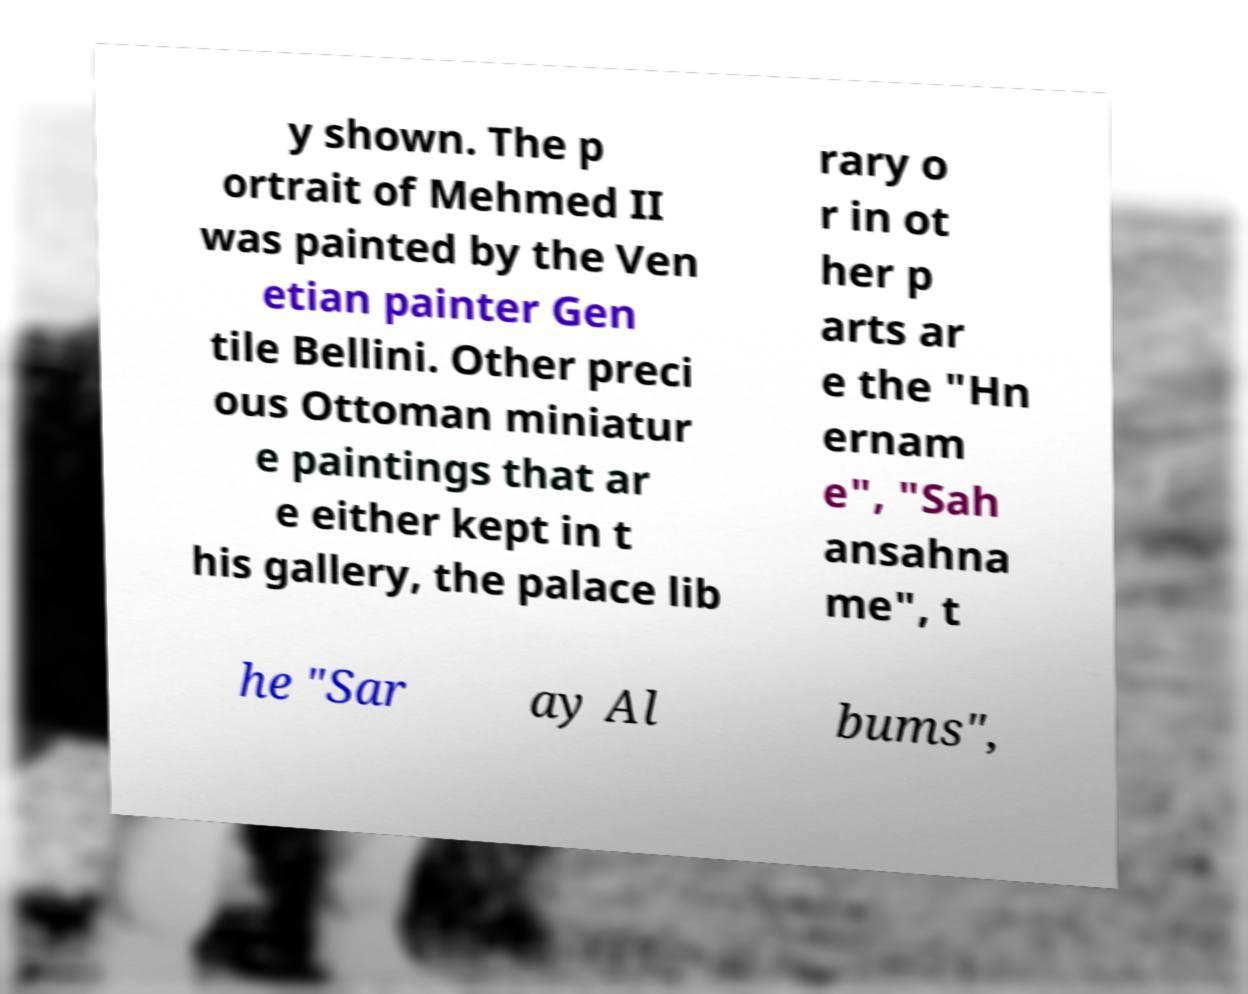Could you extract and type out the text from this image? y shown. The p ortrait of Mehmed II was painted by the Ven etian painter Gen tile Bellini. Other preci ous Ottoman miniatur e paintings that ar e either kept in t his gallery, the palace lib rary o r in ot her p arts ar e the "Hn ernam e", "Sah ansahna me", t he "Sar ay Al bums", 